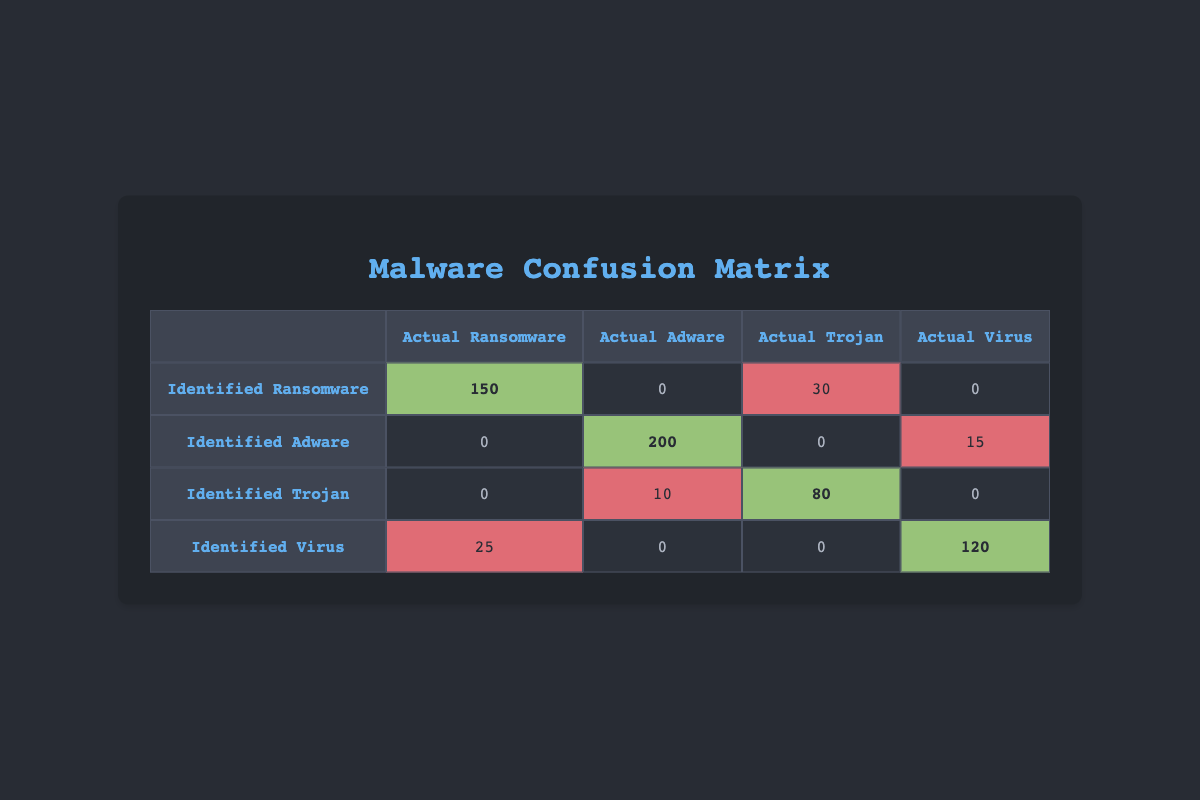What is the number of correctly identified Ransomware instances? The table shows the count for identified Ransomware, which corresponds to the Actual Ransomware. This is located on the diagonal of the matrix where identified Ransomware intersects with actual Ransomware, and the value is 150.
Answer: 150 How many instances of Adware were misidentified as Virus? Looking at the row for identified Adware, the column for actual Virus shows 15 instances. Thus, 15 instances of Adware were misidentified as Virus.
Answer: 15 What is the total number of identified Trojan instances? To find this, we sum the counts for both correctly identified Trojans (identified Trojan, actual Trojan) and misidentified counts (identified Trojan as Adware). The total is 80 (correct) + 10 (misidentified) = 90.
Answer: 90 Is there any instance where Ransomware was identified as Adware? By examining the table, there is no count for identified Ransomware in the Adware column (which would be a misidentification). The value is 0.
Answer: No What is the average number of instances for identified types that were misidentified as another type? We need to find all misidentified instances: 30 (Ransomware as Trojan) + 10 (Trojan as Adware) + 25 (Virus as Ransomware) + 15 (Adware as Virus) = 80. There are 4 misidentifications, so the average is 80 / 4 = 20.
Answer: 20 How many total instances were actually Ransomware? To compute this, we add the correctly identified instances (150) to those misidentified as Ransomware (25). Therefore, the total instances that were actually Ransomware is 150 + 25 = 175.
Answer: 175 Which type had the highest number of correct identifications? The diagonal values indicate where the identified type matches the actual type. Ransomware had the highest count on the diagonal with 150 instances.
Answer: Ransomware What is the total number of misidentified instances across all malware types? There are several misidentifications: 30 (Ransomware as Trojan) + 10 (Trojan as Adware) + 25 (Virus as Ransomware) + 15 (Adware as Virus) = 80 instances.
Answer: 80 Was the Trojan type ever identified as Ransomware? The table shows the intersection in the row for identified Trojan and the column for actual Ransomware, where the value is 0, indicating there were no occurrences.
Answer: No 